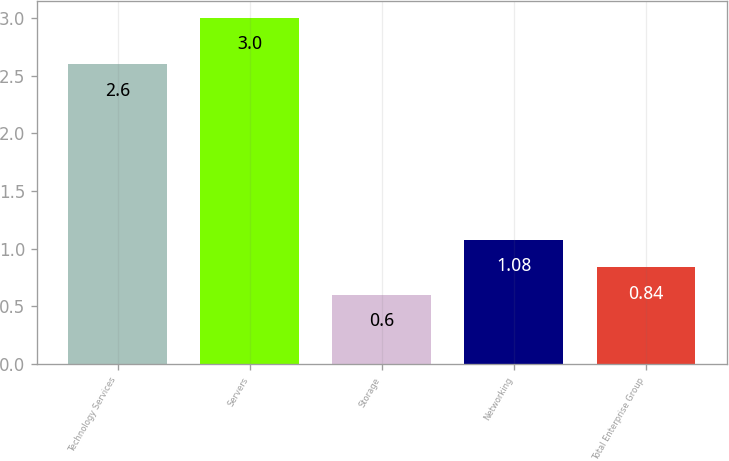Convert chart. <chart><loc_0><loc_0><loc_500><loc_500><bar_chart><fcel>Technology Services<fcel>Servers<fcel>Storage<fcel>Networking<fcel>Total Enterprise Group<nl><fcel>2.6<fcel>3<fcel>0.6<fcel>1.08<fcel>0.84<nl></chart> 